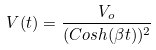<formula> <loc_0><loc_0><loc_500><loc_500>V ( t ) = \frac { V _ { o } } { ( C o s h ( \beta t ) ) ^ { 2 } }</formula> 